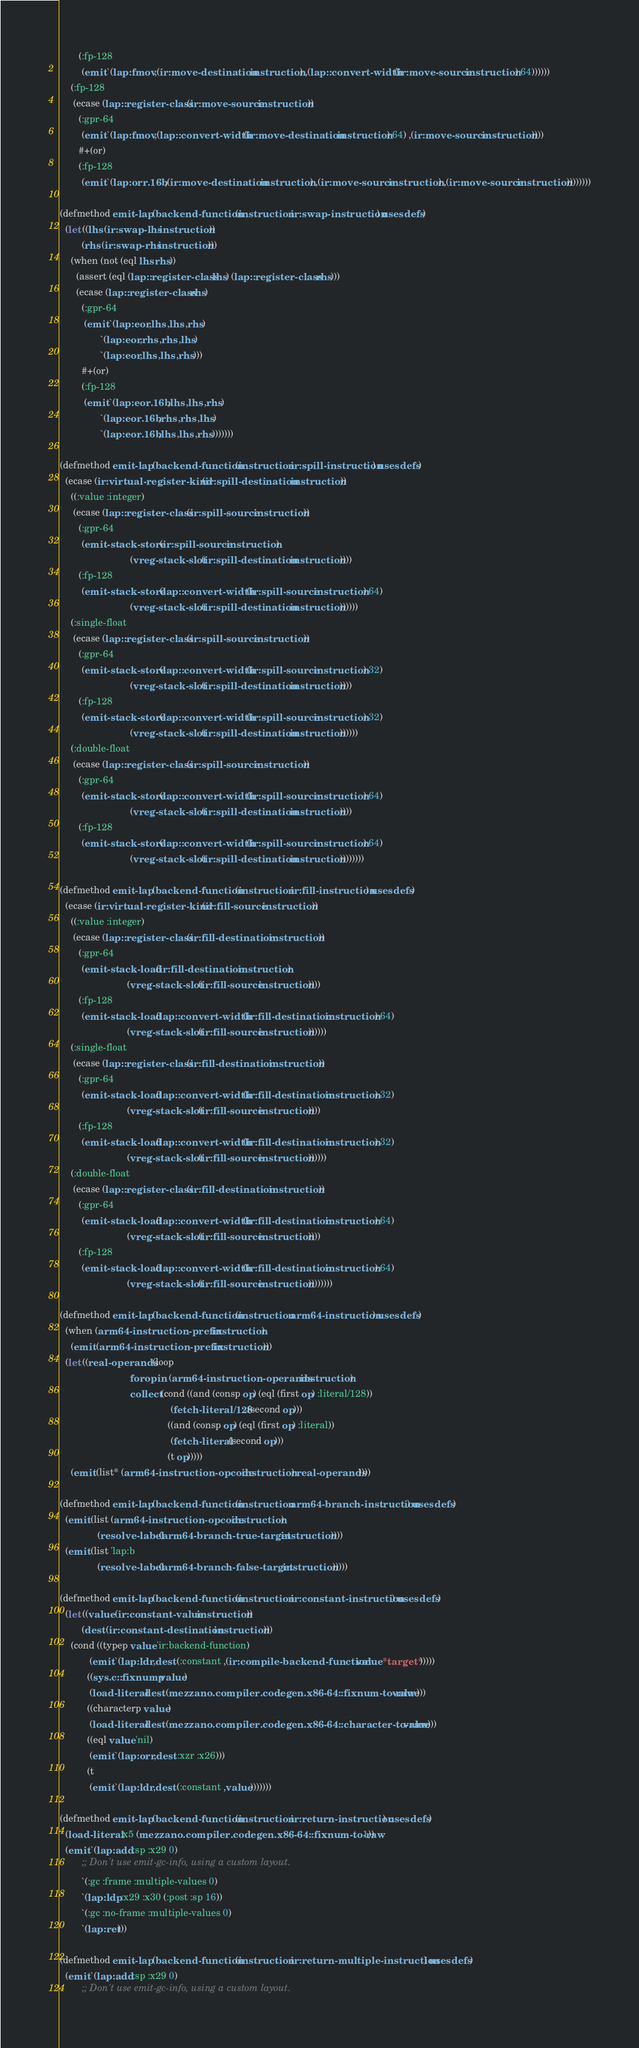<code> <loc_0><loc_0><loc_500><loc_500><_Lisp_>       (:fp-128
        (emit `(lap:fmov ,(ir:move-destination instruction) ,(lap::convert-width (ir:move-source instruction) 64))))))
    (:fp-128
     (ecase (lap::register-class (ir:move-source instruction))
       (:gpr-64
        (emit `(lap:fmov ,(lap::convert-width (ir:move-destination instruction) 64) ,(ir:move-source instruction))))
       #+(or)
       (:fp-128
        (emit `(lap:orr.16b ,(ir:move-destination instruction) ,(ir:move-source instruction) ,(ir:move-source instruction))))))))

(defmethod emit-lap (backend-function (instruction ir:swap-instruction) uses defs)
  (let ((lhs (ir:swap-lhs instruction))
        (rhs (ir:swap-rhs instruction)))
    (when (not (eql lhs rhs))
      (assert (eql (lap::register-class lhs) (lap::register-class rhs)))
      (ecase (lap::register-class rhs)
        (:gpr-64
         (emit `(lap:eor ,lhs ,lhs ,rhs)
               `(lap:eor ,rhs ,rhs ,lhs)
               `(lap:eor ,lhs ,lhs ,rhs)))
        #+(or)
        (:fp-128
         (emit `(lap:eor.16b ,lhs ,lhs ,rhs)
               `(lap:eor.16b ,rhs ,rhs ,lhs)
               `(lap:eor.16b ,lhs ,lhs ,rhs)))))))

(defmethod emit-lap (backend-function (instruction ir:spill-instruction) uses defs)
  (ecase (ir:virtual-register-kind (ir:spill-destination instruction))
    ((:value :integer)
     (ecase (lap::register-class (ir:spill-source instruction))
       (:gpr-64
        (emit-stack-store (ir:spill-source instruction)
                          (vreg-stack-slot (ir:spill-destination instruction))))
       (:fp-128
        (emit-stack-store (lap::convert-width (ir:spill-source instruction) 64)
                          (vreg-stack-slot (ir:spill-destination instruction))))))
    (:single-float
     (ecase (lap::register-class (ir:spill-source instruction))
       (:gpr-64
        (emit-stack-store (lap::convert-width (ir:spill-source instruction) 32)
                          (vreg-stack-slot (ir:spill-destination instruction))))
       (:fp-128
        (emit-stack-store (lap::convert-width (ir:spill-source instruction) 32)
                          (vreg-stack-slot (ir:spill-destination instruction))))))
    (:double-float
     (ecase (lap::register-class (ir:spill-source instruction))
       (:gpr-64
        (emit-stack-store (lap::convert-width (ir:spill-source instruction) 64)
                          (vreg-stack-slot (ir:spill-destination instruction))))
       (:fp-128
        (emit-stack-store (lap::convert-width (ir:spill-source instruction) 64)
                          (vreg-stack-slot (ir:spill-destination instruction))))))))

(defmethod emit-lap (backend-function (instruction ir:fill-instruction) uses defs)
  (ecase (ir:virtual-register-kind (ir:fill-source instruction))
    ((:value :integer)
     (ecase (lap::register-class (ir:fill-destination instruction))
       (:gpr-64
        (emit-stack-load (ir:fill-destination instruction)
                         (vreg-stack-slot (ir:fill-source instruction))))
       (:fp-128
        (emit-stack-load (lap::convert-width (ir:fill-destination instruction) 64)
                         (vreg-stack-slot (ir:fill-source instruction))))))
    (:single-float
     (ecase (lap::register-class (ir:fill-destination instruction))
       (:gpr-64
        (emit-stack-load (lap::convert-width (ir:fill-destination instruction) 32)
                         (vreg-stack-slot (ir:fill-source instruction))))
       (:fp-128
        (emit-stack-load (lap::convert-width (ir:fill-destination instruction) 32)
                         (vreg-stack-slot (ir:fill-source instruction))))))
    (:double-float
     (ecase (lap::register-class (ir:fill-destination instruction))
       (:gpr-64
        (emit-stack-load (lap::convert-width (ir:fill-destination instruction) 64)
                         (vreg-stack-slot (ir:fill-source instruction))))
       (:fp-128
        (emit-stack-load (lap::convert-width (ir:fill-destination instruction) 64)
                         (vreg-stack-slot (ir:fill-source instruction))))))))

(defmethod emit-lap (backend-function (instruction arm64-instruction) uses defs)
  (when (arm64-instruction-prefix instruction)
    (emit (arm64-instruction-prefix instruction)))
  (let ((real-operands (loop
                          for op in (arm64-instruction-operands instruction)
                          collect (cond ((and (consp op) (eql (first op) :literal/128))
                                         (fetch-literal/128 (second op)))
                                        ((and (consp op) (eql (first op) :literal))
                                         (fetch-literal (second op)))
                                        (t op)))))
    (emit (list* (arm64-instruction-opcode instruction) real-operands))))

(defmethod emit-lap (backend-function (instruction arm64-branch-instruction) uses defs)
  (emit (list (arm64-instruction-opcode instruction)
              (resolve-label (arm64-branch-true-target instruction))))
  (emit (list 'lap:b
              (resolve-label (arm64-branch-false-target instruction)))))

(defmethod emit-lap (backend-function (instruction ir:constant-instruction) uses defs)
  (let ((value (ir:constant-value instruction))
        (dest (ir:constant-destination instruction)))
    (cond ((typep value 'ir:backend-function)
           (emit `(lap:ldr ,dest (:constant ,(ir:compile-backend-function value *target*)))))
          ((sys.c::fixnump value)
           (load-literal dest (mezzano.compiler.codegen.x86-64::fixnum-to-raw value)))
          ((characterp value)
           (load-literal dest (mezzano.compiler.codegen.x86-64::character-to-raw value)))
          ((eql value 'nil)
           (emit `(lap:orr ,dest :xzr :x26)))
          (t
           (emit `(lap:ldr ,dest (:constant ,value)))))))

(defmethod emit-lap (backend-function (instruction ir:return-instruction) uses defs)
  (load-literal :x5 (mezzano.compiler.codegen.x86-64::fixnum-to-raw 1))
  (emit `(lap:add :sp :x29 0)
        ;; Don't use emit-gc-info, using a custom layout.
        `(:gc :frame :multiple-values 0)
        `(lap:ldp :x29 :x30 (:post :sp 16))
        `(:gc :no-frame :multiple-values 0)
        `(lap:ret)))

(defmethod emit-lap (backend-function (instruction ir:return-multiple-instruction) uses defs)
  (emit `(lap:add :sp :x29 0)
        ;; Don't use emit-gc-info, using a custom layout.</code> 